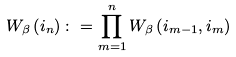<formula> <loc_0><loc_0><loc_500><loc_500>W _ { \beta } \left ( i _ { n } \right ) \colon = \prod _ { m = 1 } ^ { n } W _ { \beta } \left ( i _ { m - 1 } , i _ { m } \right )</formula> 